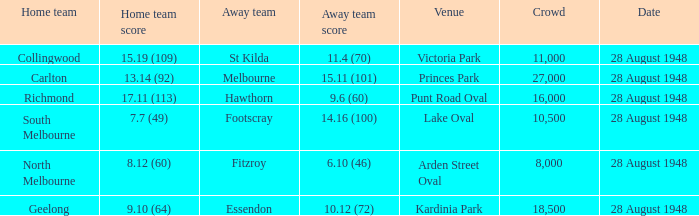What home team has a team score of 8.12 (60)? North Melbourne. 